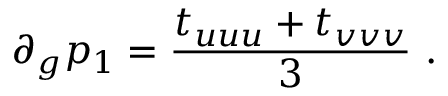Convert formula to latex. <formula><loc_0><loc_0><loc_500><loc_500>\partial _ { g } p _ { 1 } = { \frac { t _ { u u u } + t _ { v v v } } { 3 } } \ .</formula> 